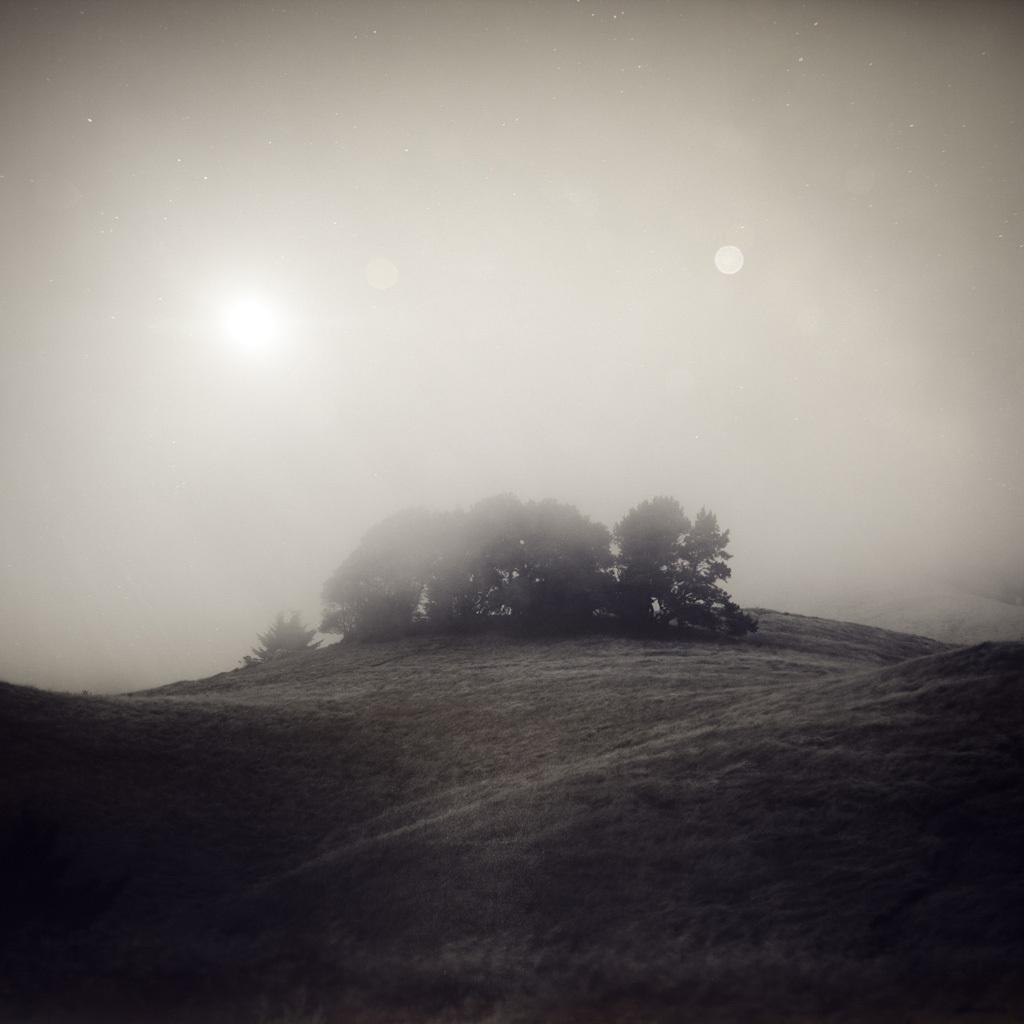What type of view is shown in the image? The image is an outside view. What can be seen at the bottom of the image? The ground is visible at the bottom of the image. What is present in the background of the image? There are trees in the background of the image. How are the trees depicted in the image? The trees are in the fog. Where is the sun located in the image? The sun is visible on the left side of the image. What type of camera is used to take the picture of the lunch in the image? There is no lunch or camera present in the image; it shows an outside view with trees in the fog and the sun on the left side. 